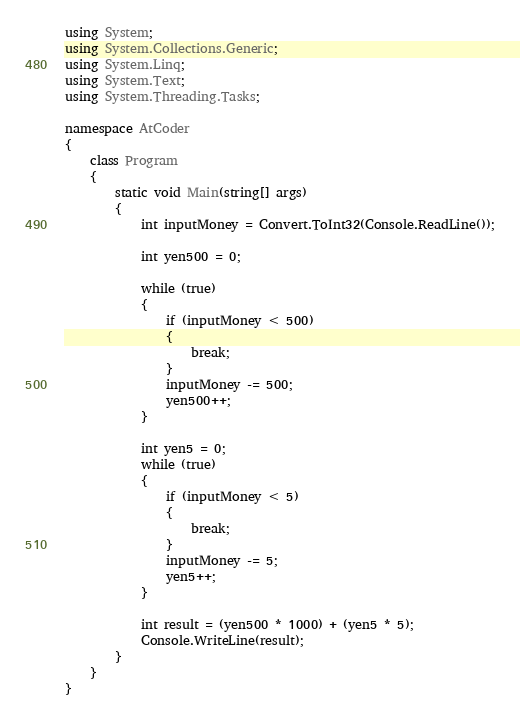Convert code to text. <code><loc_0><loc_0><loc_500><loc_500><_C#_>using System;
using System.Collections.Generic;
using System.Linq;
using System.Text;
using System.Threading.Tasks;

namespace AtCoder
{
    class Program
    {
        static void Main(string[] args)
        {
            int inputMoney = Convert.ToInt32(Console.ReadLine());

            int yen500 = 0;

            while (true)
            {
                if (inputMoney < 500)
                {
                    break;
                }
                inputMoney -= 500;
                yen500++;
            }

            int yen5 = 0;
            while (true)
            {
                if (inputMoney < 5)
                {
                    break;
                }
                inputMoney -= 5;
                yen5++;
            }

            int result = (yen500 * 1000) + (yen5 * 5);
            Console.WriteLine(result);
        }
    }
}
</code> 